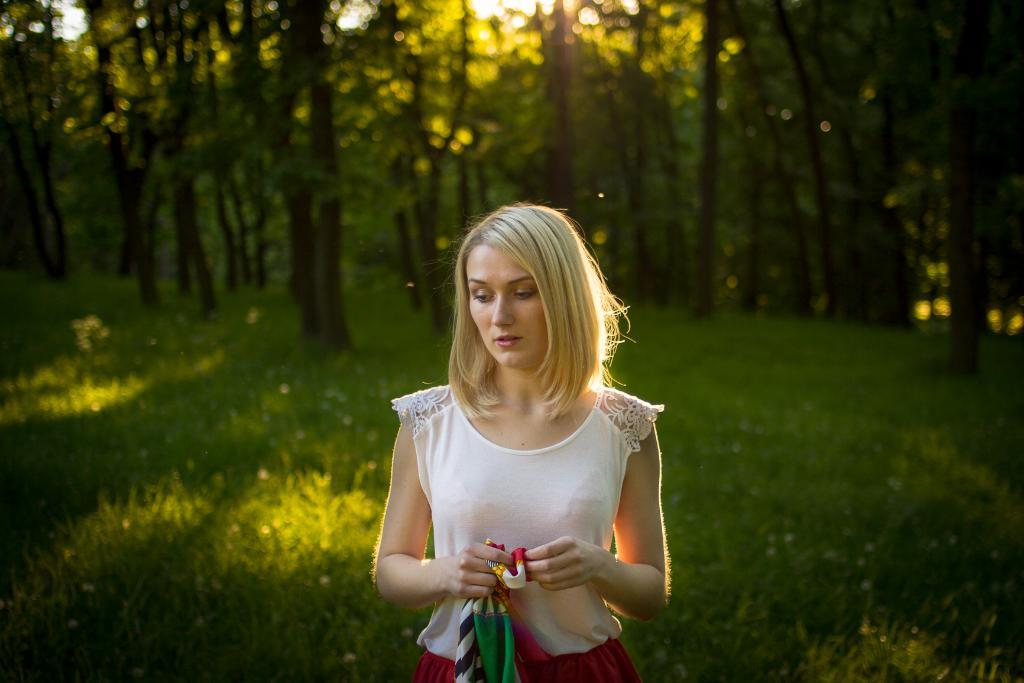Who is the main subject in the foreground of the image? There is a woman in the foreground of the image. What is the woman holding in the image? The woman is holding a scarf. What type of vegetation can be seen in the background of the image? There are trees in the background of the image. What type of ground is visible at the bottom of the image? There is grass visible at the bottom of the image. What type of horn can be seen in the image? There is no horn present in the image. 